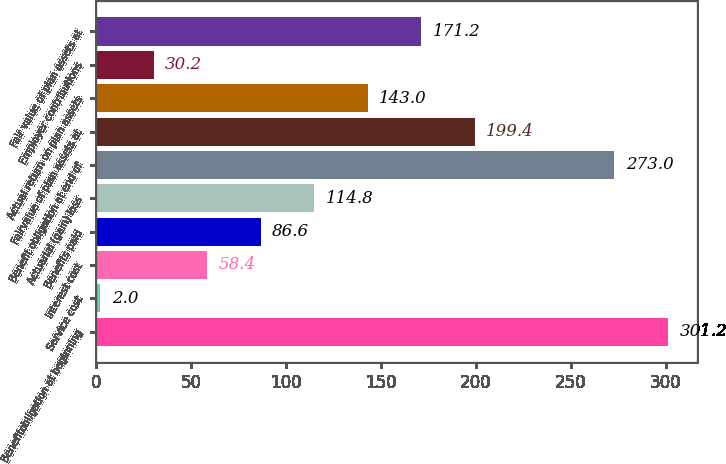<chart> <loc_0><loc_0><loc_500><loc_500><bar_chart><fcel>Benefitobligation at beginning<fcel>Service cost<fcel>Interest cost<fcel>Benefits paid<fcel>Actuarial (gain) loss<fcel>Benefit obligation at end of<fcel>Fairvalue of plan assets at<fcel>Actual return on plan assets<fcel>Employer contributions<fcel>Fair value of plan assets at<nl><fcel>301.2<fcel>2<fcel>58.4<fcel>86.6<fcel>114.8<fcel>273<fcel>199.4<fcel>143<fcel>30.2<fcel>171.2<nl></chart> 